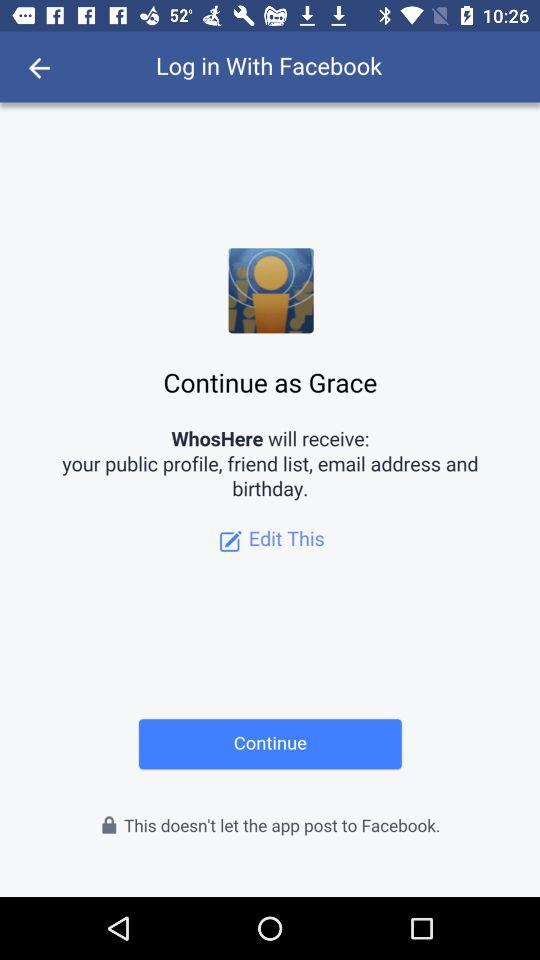What application is asking for permission? The application asking for permission is "WhosHere". 